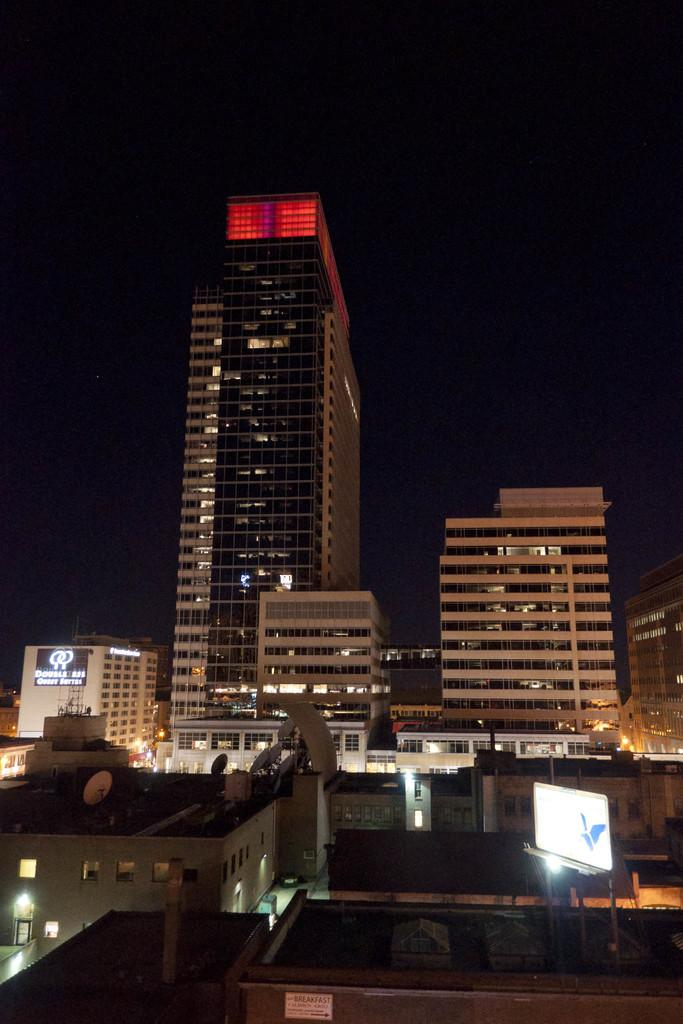What type of lighting is present in the image? There are lights in the image. What structures are visible in the image? There are boards and tower buildings in the image. What type of light boards are present in the image? There are LED light boards in the image. What can be observed about the sky in the background of the image? The sky in the background is dark. Can you tell me how many bees are flying around the LED light boards in the image? There are no bees present in the image; it only features lights, boards, tower buildings, and LED light boards. What is the reason for the partnership between the lights and the boards in the image? There is no partnership mentioned or implied in the image; it simply shows lights, boards, tower buildings, and LED light boards. 